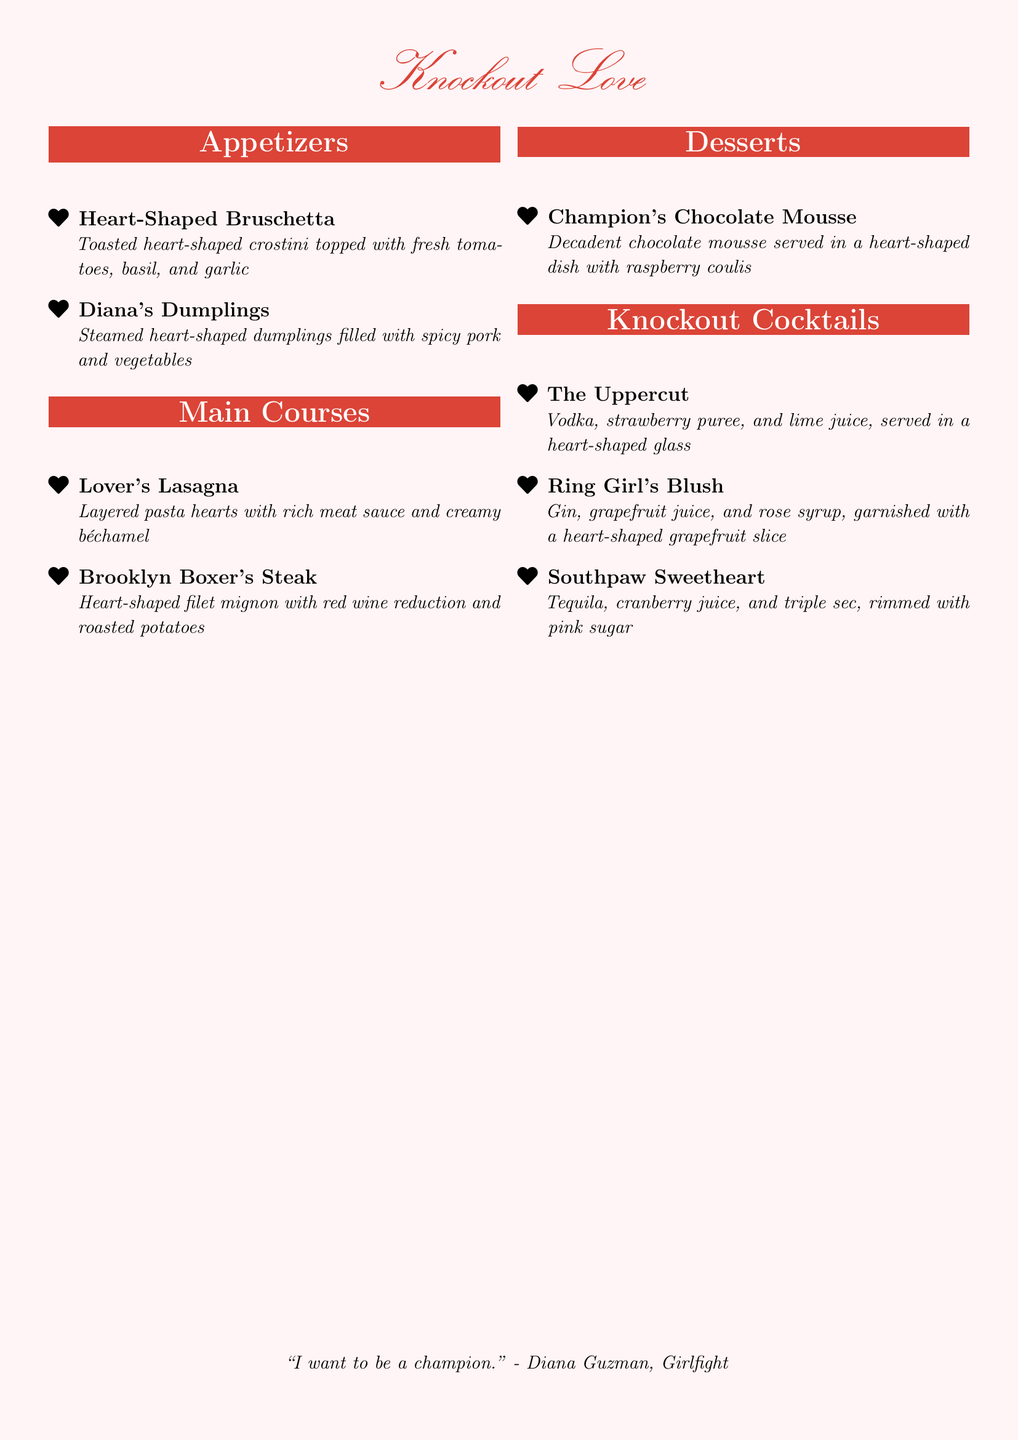What is the name of the romantic menu? The title of the romantic menu is prominently displayed at the beginning of the document.
Answer: Knockout Love How many appetizers are listed on the menu? The number of appetizers is indicated by counting the items in the 'Appetizers' section.
Answer: 2 What is the main ingredient of 'Diana's Dumplings'? The ingredient is mentioned in the description of the dish in the menu.
Answer: Spicy pork Which dessert is featured on the menu? The dessert is specified under the 'Desserts' section of the menu.
Answer: Champion's Chocolate Mousse What drink is served in a heart-shaped glass? This drink is named in the 'Knockout Cocktails' section.
Answer: The Uppercut What is the main protein in the 'Brooklyn Boxer's Steak'? The protein content can be derived from the name and description of the dish on the menu.
Answer: Filet mignon How many 'Knockout Cocktails' are listed? The total number of cocktails is found by counting items in the 'Knockout Cocktails' section.
Answer: 3 Which cocktail includes gin? This is determined by looking at the 'Knockout Cocktails' section and identifying the drink with gin in its ingredients.
Answer: Ring Girl's Blush What type of dish is 'Lover's Lasagna'? The type of dish is specified in the main courses section.
Answer: Pasta hearts 